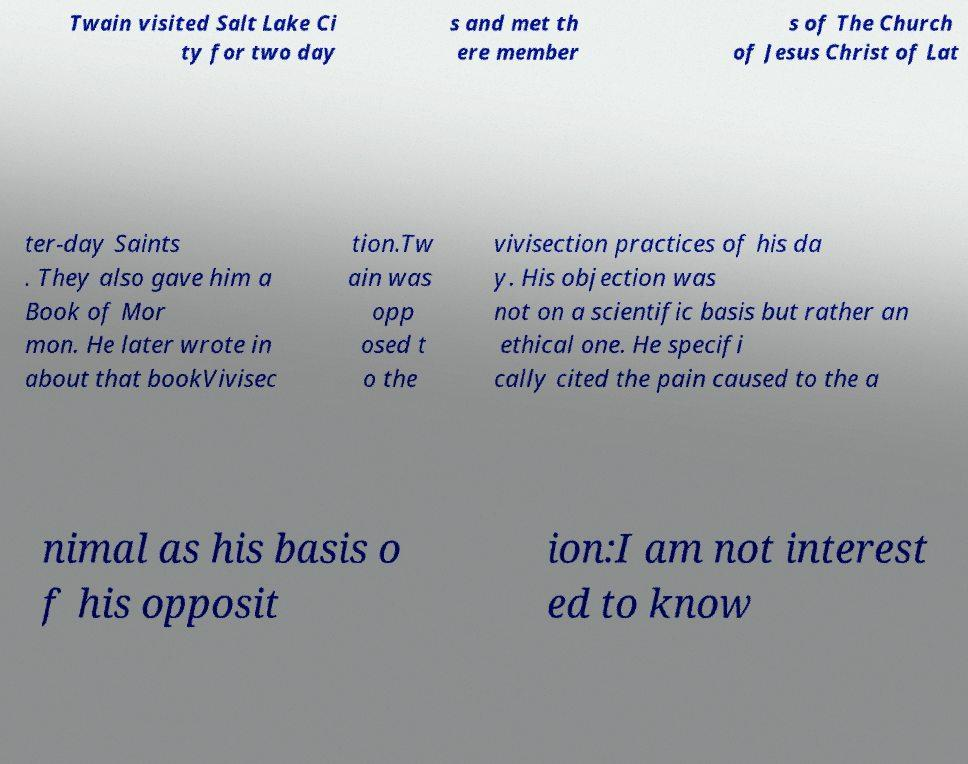Please identify and transcribe the text found in this image. Twain visited Salt Lake Ci ty for two day s and met th ere member s of The Church of Jesus Christ of Lat ter-day Saints . They also gave him a Book of Mor mon. He later wrote in about that bookVivisec tion.Tw ain was opp osed t o the vivisection practices of his da y. His objection was not on a scientific basis but rather an ethical one. He specifi cally cited the pain caused to the a nimal as his basis o f his opposit ion:I am not interest ed to know 